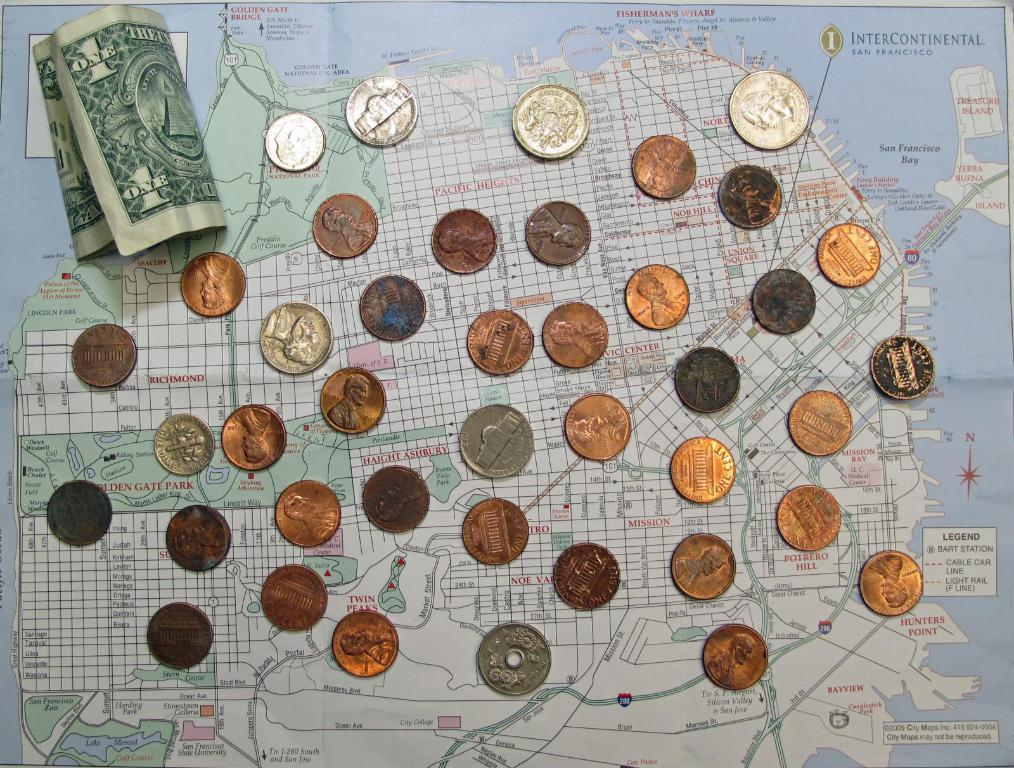<image>
Present a compact description of the photo's key features. A dollar bill and a bunch of coins are spread out on top of a San Francisco area map. 